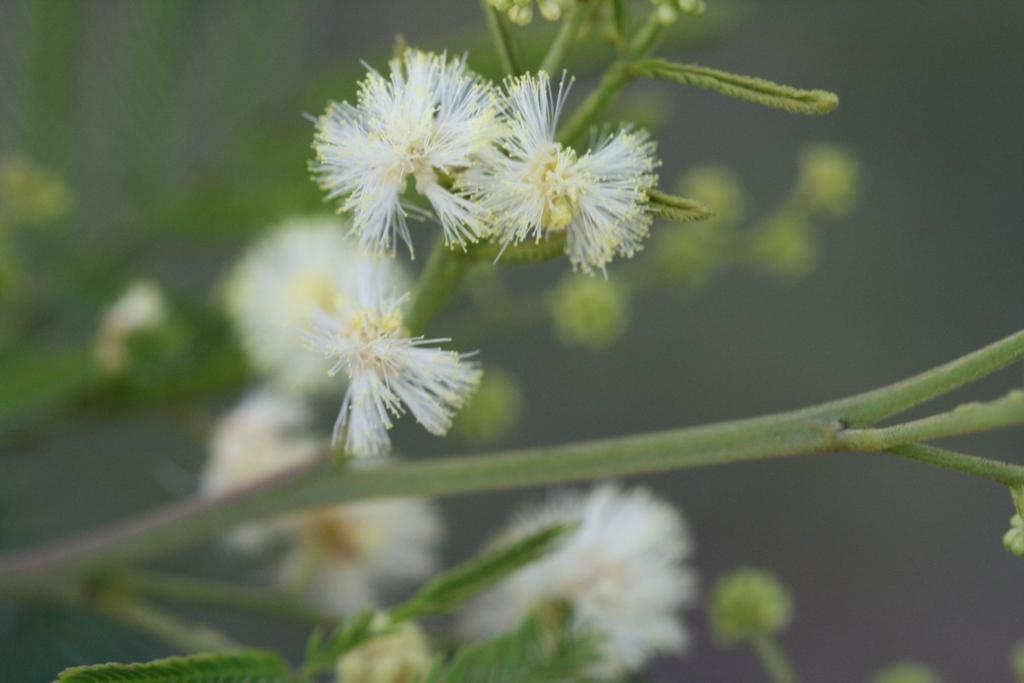What type of plant is depicted in the image? The flowers and leaves in the image belong to a shame plant. What other elements can be seen in the image besides the plant? There are no other elements mentioned in the provided facts. What color is the crayon used to draw the cart in the image? There is no crayon or cart present in the image; it only features a shame plant with flowers and leaves. 